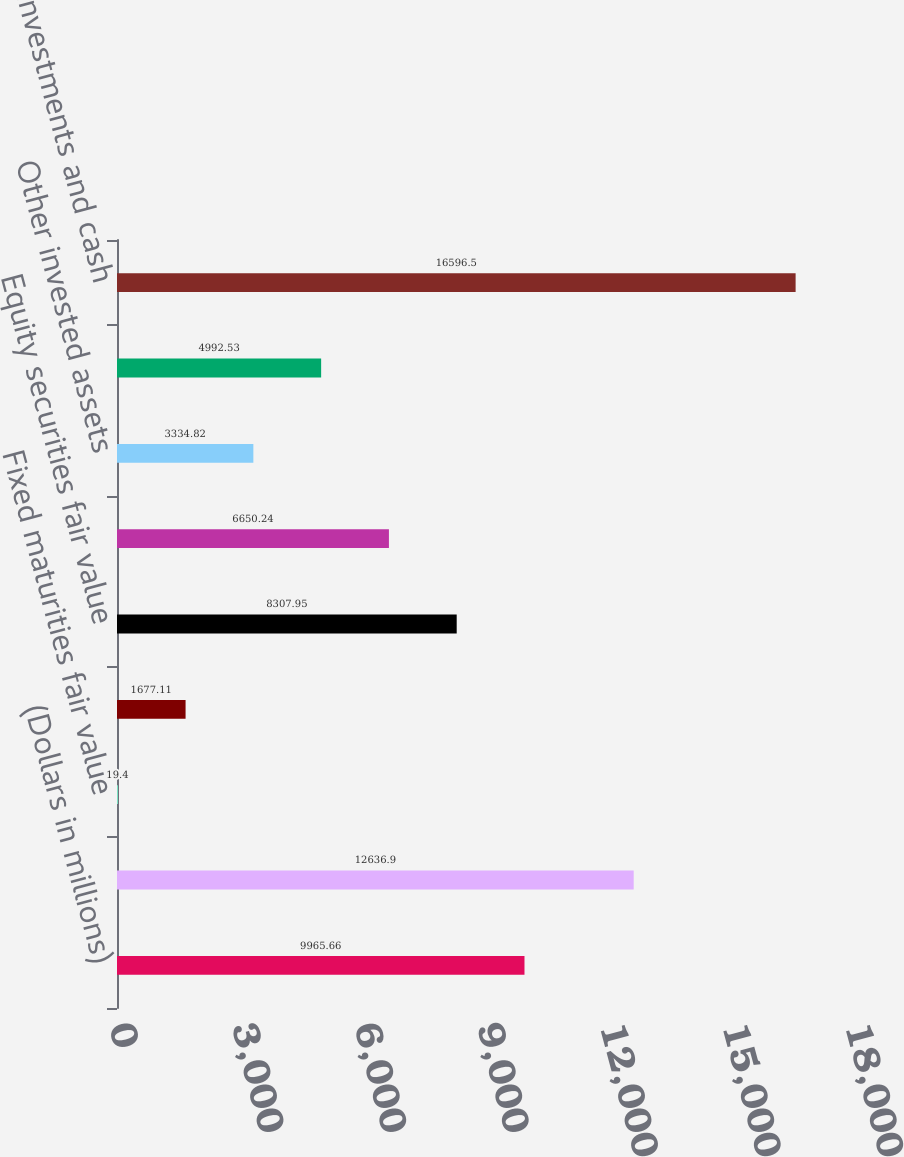Convert chart. <chart><loc_0><loc_0><loc_500><loc_500><bar_chart><fcel>(Dollars in millions)<fcel>Fixed maturities market value<fcel>Fixed maturities fair value<fcel>Equity securities market value<fcel>Equity securities fair value<fcel>Short-term investments<fcel>Other invested assets<fcel>Cash<fcel>Total investments and cash<nl><fcel>9965.66<fcel>12636.9<fcel>19.4<fcel>1677.11<fcel>8307.95<fcel>6650.24<fcel>3334.82<fcel>4992.53<fcel>16596.5<nl></chart> 